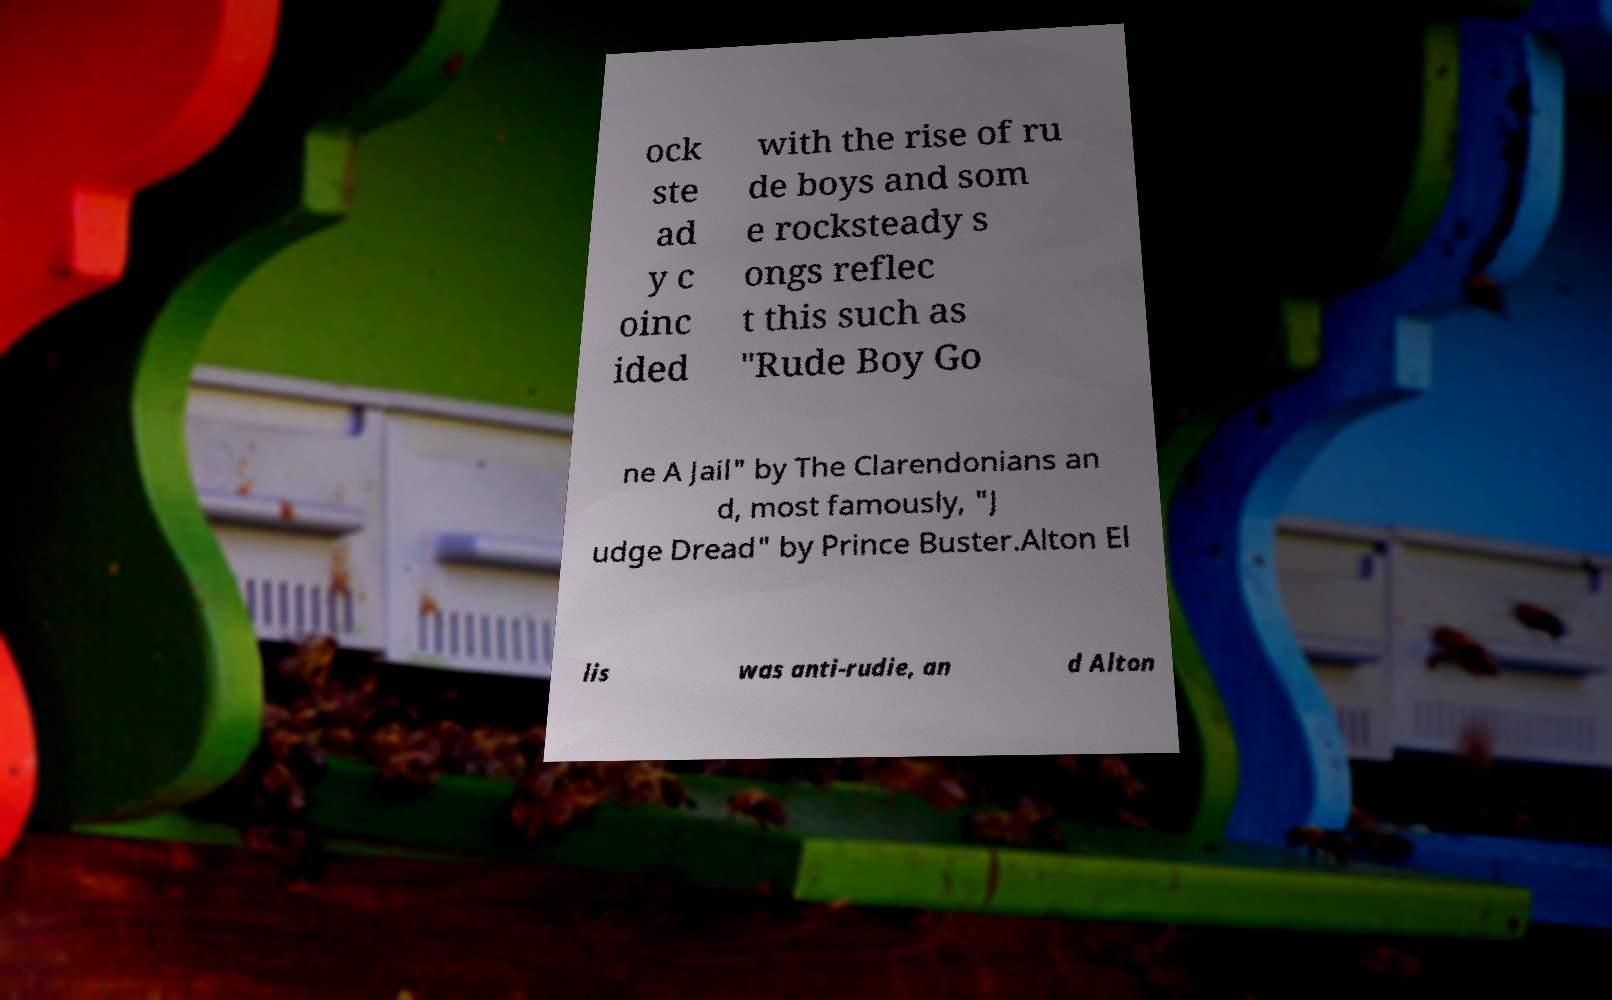Could you extract and type out the text from this image? ock ste ad y c oinc ided with the rise of ru de boys and som e rocksteady s ongs reflec t this such as "Rude Boy Go ne A Jail" by The Clarendonians an d, most famously, "J udge Dread" by Prince Buster.Alton El lis was anti-rudie, an d Alton 